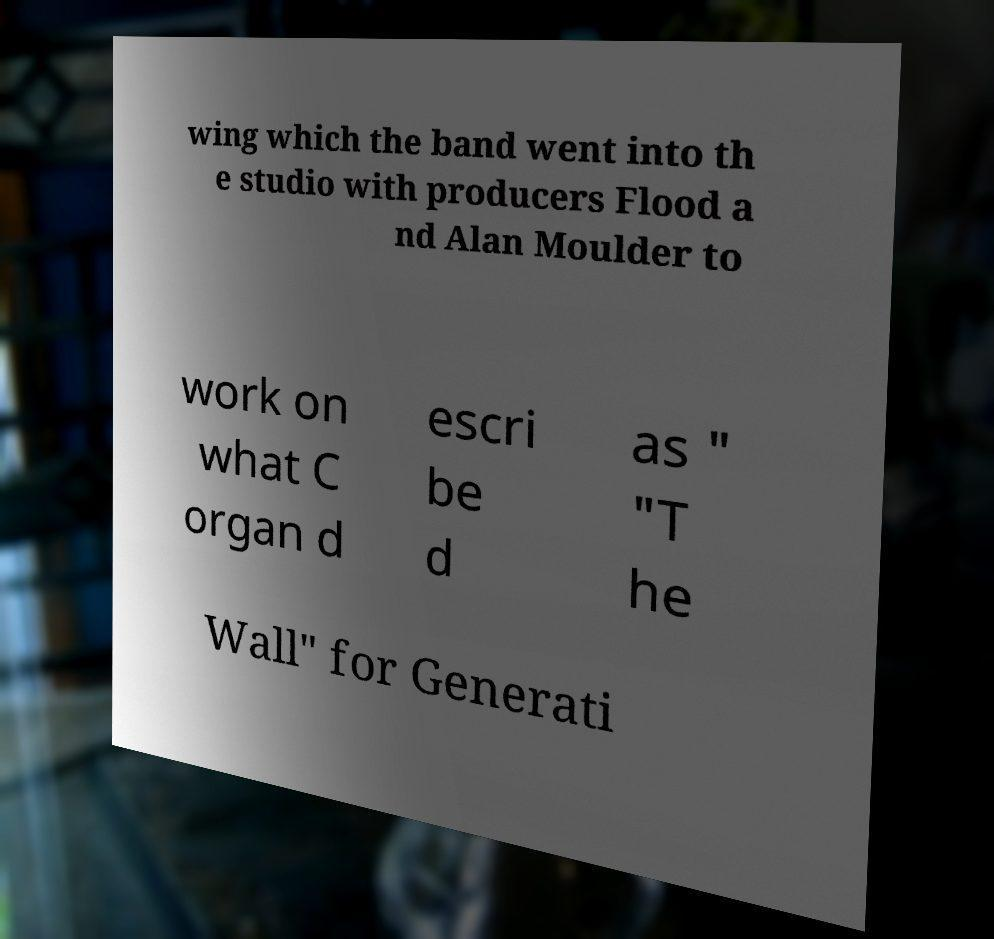Can you accurately transcribe the text from the provided image for me? wing which the band went into th e studio with producers Flood a nd Alan Moulder to work on what C organ d escri be d as " "T he Wall" for Generati 